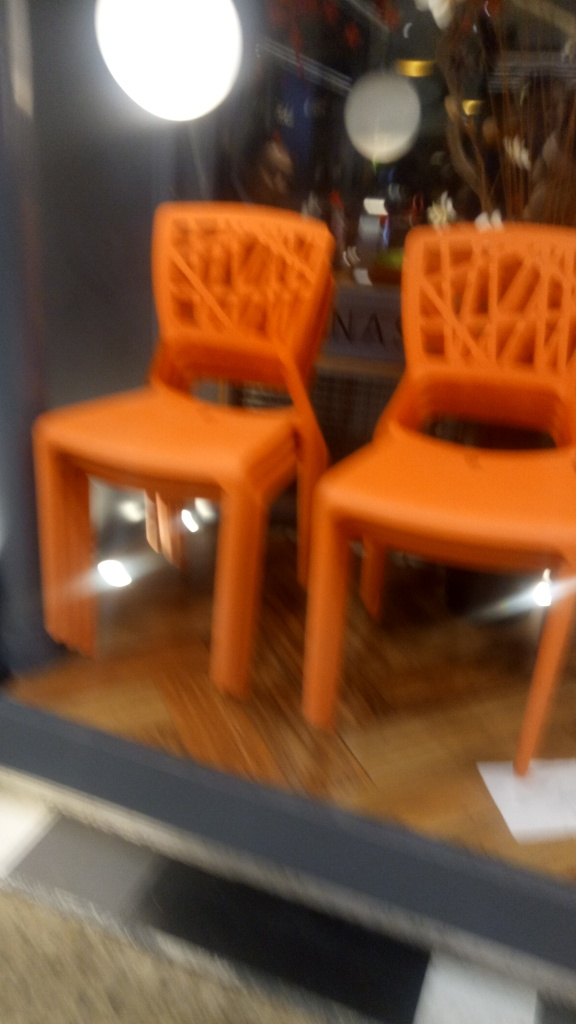How might the composition of the image affect a viewer's impression? The lack of focus and the angle from which the photo is taken might give viewers an impression of being in a rush or catching a glimpse of something as they pass by. The arrangement also leaves much to the imagination, as the context and purpose of the chairs are not fully explained, inviting viewers to fill in the gaps with their own interpretations. 